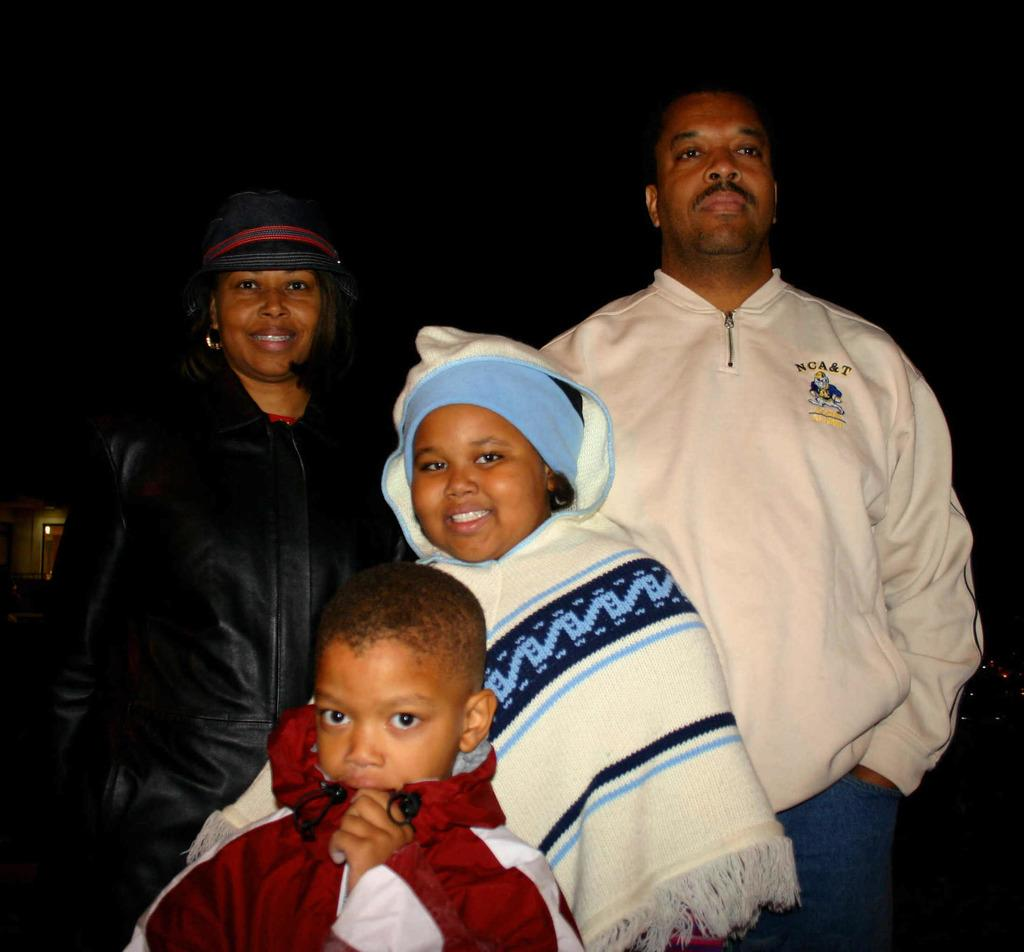How many people are in the image? There are four persons standing in the image. Where are the persons located in the image? The persons are at the front of the image. What can be seen in the background of the image? There is a building in the background of the image. Can you tell me how many horses are visible in the image? There are no horses present in the image. Is there a tree in the image? There is no tree mentioned in the provided facts, so we cannot determine if a tree is present in the image. 